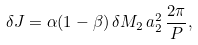Convert formula to latex. <formula><loc_0><loc_0><loc_500><loc_500>\delta J = \alpha ( 1 - \beta ) \, \delta M _ { 2 } \, a _ { 2 } ^ { 2 } \, \frac { 2 \pi } { P } ,</formula> 